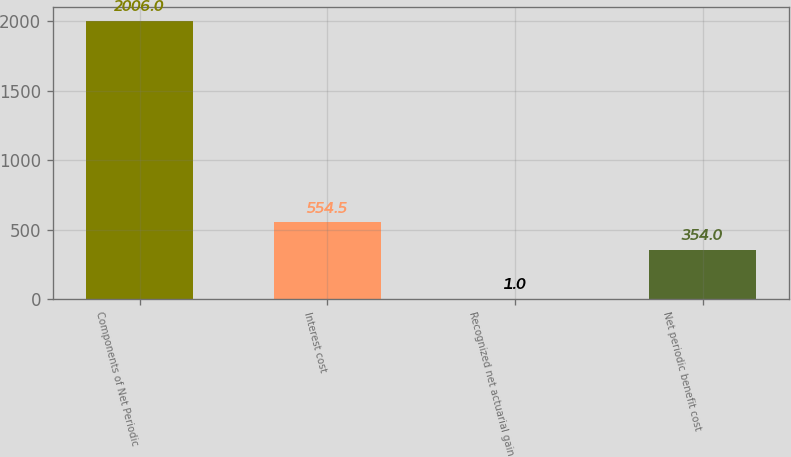Convert chart to OTSL. <chart><loc_0><loc_0><loc_500><loc_500><bar_chart><fcel>Components of Net Periodic<fcel>Interest cost<fcel>Recognized net actuarial gain<fcel>Net periodic benefit cost<nl><fcel>2006<fcel>554.5<fcel>1<fcel>354<nl></chart> 